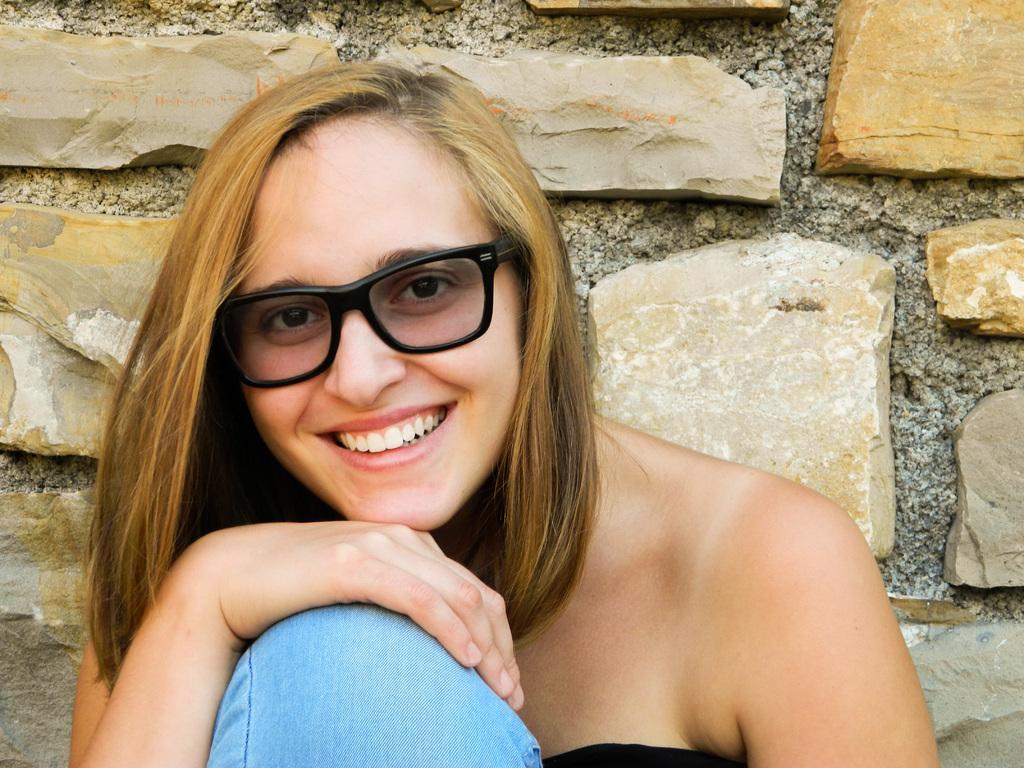Could you give a brief overview of what you see in this image? In this image, we can see a woman, she is smiling. In the background, we can see the wall. 